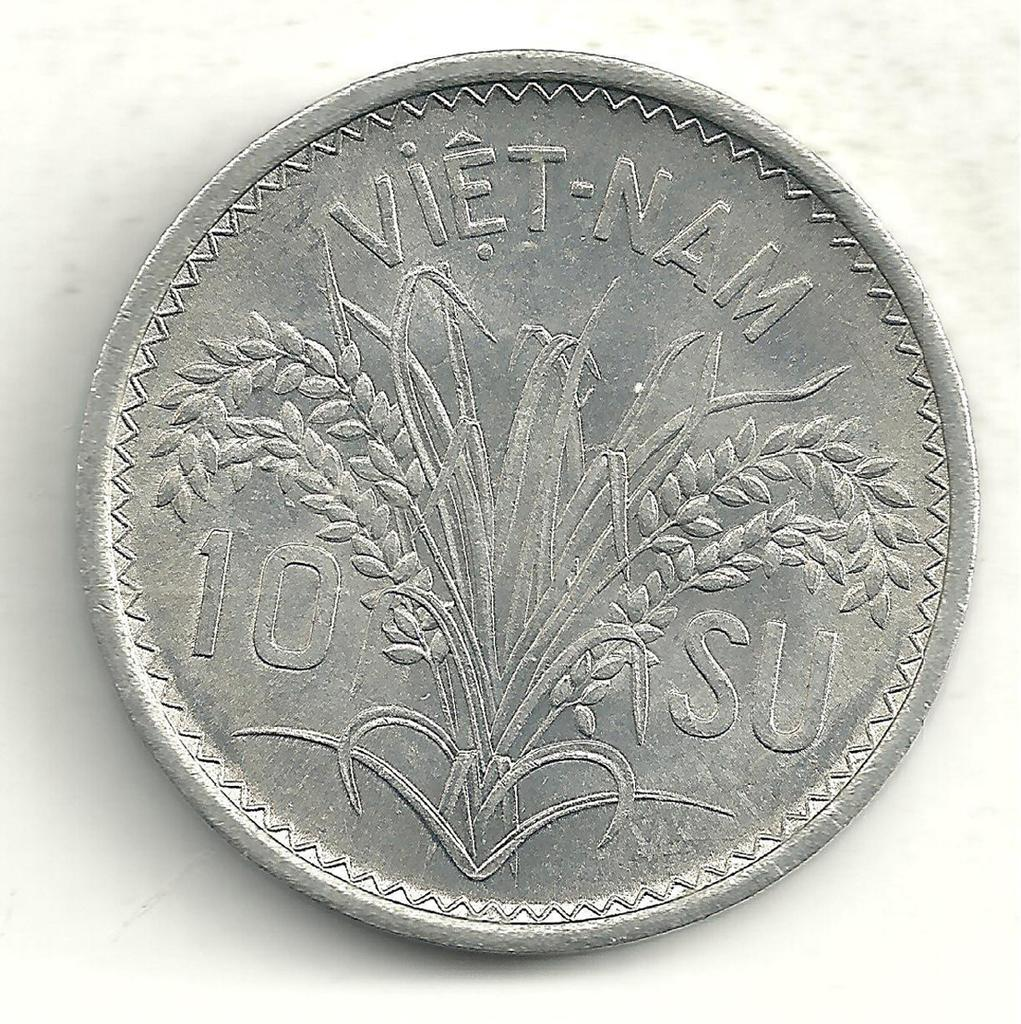<image>
Offer a succinct explanation of the picture presented. Silver coin with Viet-Nam 10 SU printed on the top and side of the wheat design. 